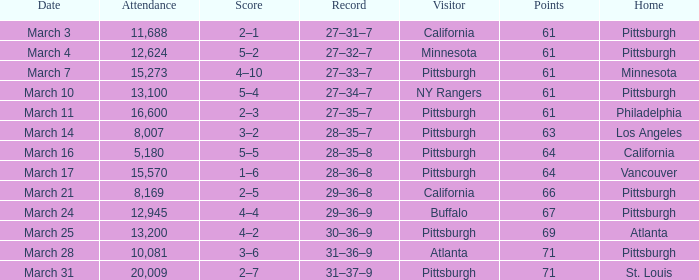What is the Score of the game with a Record of 31–37–9? 2–7. 